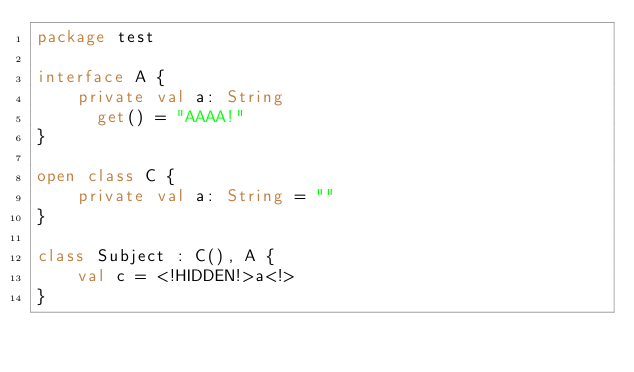<code> <loc_0><loc_0><loc_500><loc_500><_Kotlin_>package test

interface A {
    private val a: String
      get() = "AAAA!"
}

open class C {
    private val a: String = ""
}

class Subject : C(), A {
    val c = <!HIDDEN!>a<!>
}
</code> 